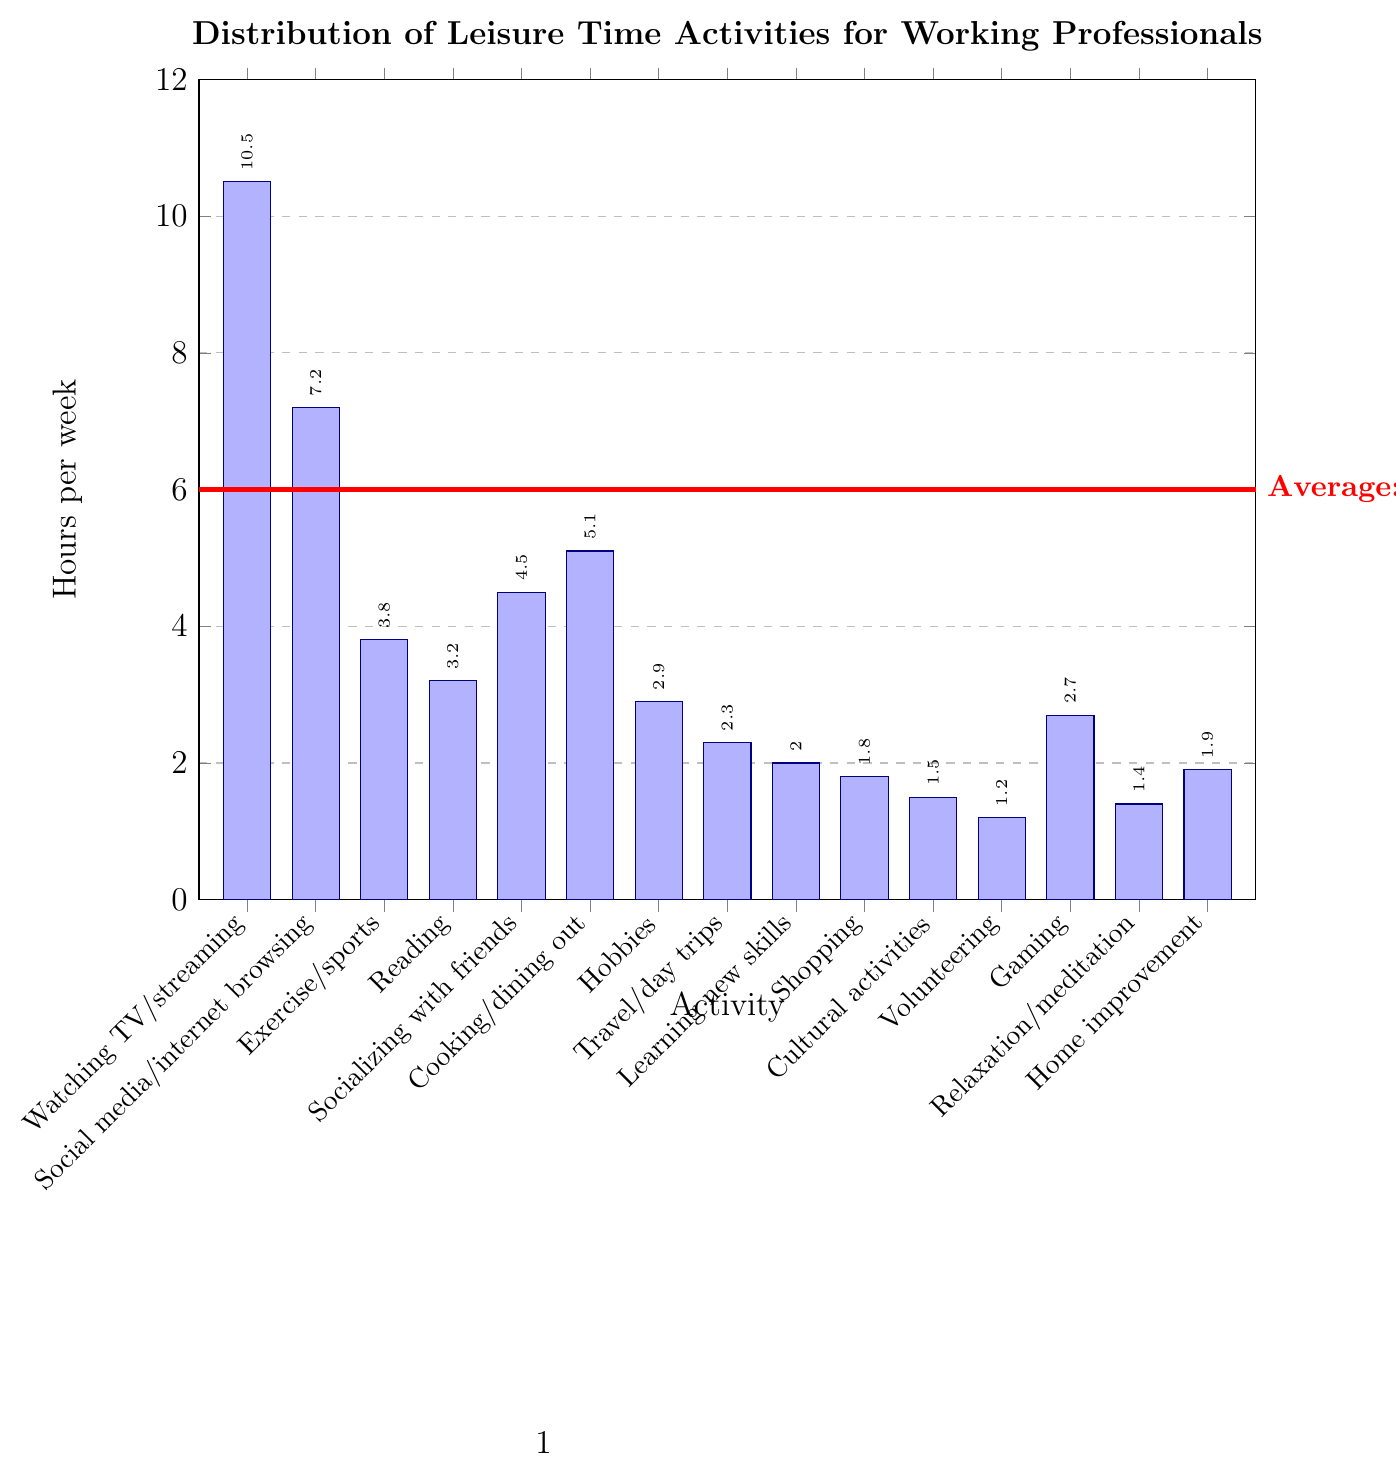What's the most popular leisure activity among working professionals? The tallest bar in the chart represents the most popular activity. The height of the bar for "Watching TV/streaming" is 10.5 hours, which is the highest among all activities.
Answer: Watching TV/streaming Which activity takes up more weekly hours: Exercise/sports or Socializing with friends? By comparing the heights of the bars, the bar for "Socializing with friends" is taller than the bar for "Exercise/sports". "Socializing with friends" has 4.5 hours while "Exercise/sports" has 3.8 hours.
Answer: Socializing with friends What is the total time spent on activities related to socializing (socializing with friends and social media/internet browsing)? Sum the hours spent on "Socializing with friends" (4.5 hours) and "Social media/internet browsing" (7.2 hours). 4.5 + 7.2 = 11.7 hours.
Answer: 11.7 hours What is the difference in hours spent between the least and most popular activities? The most popular activity is "Watching TV/streaming" with 10.5 hours, and the least popular is "Volunteering" with 1.2 hours. The difference is calculated as 10.5 - 1.2.
Answer: 9.3 hours How many activities fall below the average of 3.47 hours per week? Count the number of bars that are below the 3.47 hours mark indicated by the red line on the chart: Reading, Hobbies, Travel/day trips, Learning new skills, Shopping, Cultural activities, Volunteering, Gaming, Relaxation/meditation, Home improvement.
Answer: 10 Is the time spent on "Gaming" higher or lower than the average of 3.47 hours per week? The height of the bar for "Gaming" is 2.7 hours, which is below the average indicated by the red line.
Answer: Lower Which activities have a weekly time close to 2 hours, and what are their exact values? The bar for "Travel/day trips" is at 2.3 hours, "Learning new skills" is at 2.0 hours, "Gaming" is at 2.7 hours, "Home improvement" is at 1.9 hours, and "Shopping" is at 1.8 hours. These values are close to 2 hours.
Answer: Travel/day trips: 2.3, Learning new skills: 2.0, Gaming: 2.7, Home improvement: 1.9, Shopping: 1.8 What is the sum of hours spent on "Cooking/dining out" and "Hobbies"? Sum the hours from the bars for "Cooking/dining out" (5.1 hours) and "Hobbies" (2.9 hours). 5.1 + 2.9 = 8.0 hours.
Answer: 8.0 hours Are there more hours spent on "Reading" or "Gaming"? Compare the heights of the bars for "Reading" (3.2 hours) and "Gaming" (2.7 hours). The bar for "Reading" is taller.
Answer: Reading What is the proportion of hours spent on "Social media/internet browsing" relative to "Watching TV/streaming"? Calculate the ratio of hours spent on "Social media/internet browsing" (7.2 hours) to "Watching TV/streaming" (10.5 hours). 7.2 / 10.5 = approximately 0.686 or 68.6%.
Answer: Approximately 68.6% 